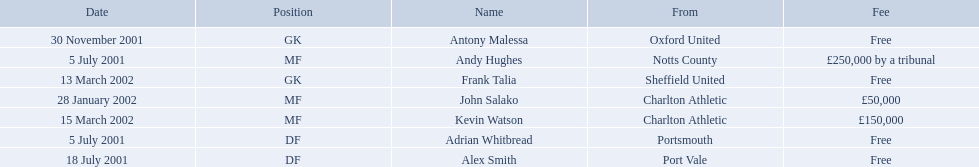Who are all the players? Andy Hughes, Adrian Whitbread, Alex Smith, Antony Malessa, John Salako, Frank Talia, Kevin Watson. What were their fees? £250,000 by a tribunal, Free, Free, Free, £50,000, Free, £150,000. And how much was kevin watson's fee? £150,000. 